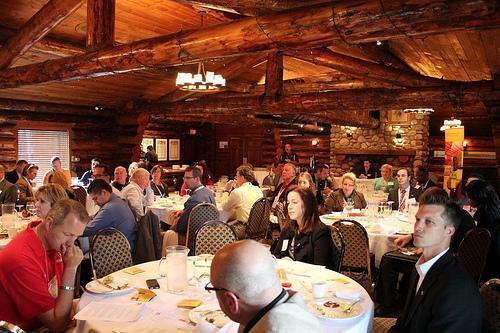How many windows are there?
Give a very brief answer. 1. 